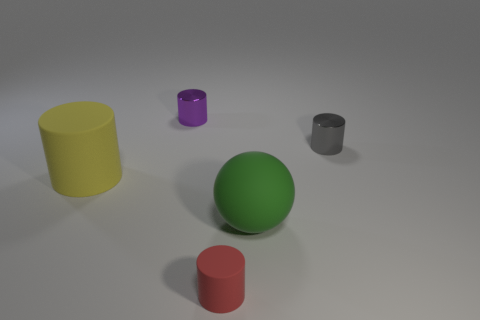The purple object that is the same shape as the red rubber object is what size?
Your answer should be very brief. Small. Are there any blue matte things that have the same shape as the tiny gray metallic thing?
Offer a terse response. No. Is the tiny cylinder right of the rubber ball made of the same material as the small cylinder on the left side of the red cylinder?
Provide a succinct answer. Yes. How many purple cylinders are made of the same material as the small red object?
Give a very brief answer. 0. The small matte thing is what color?
Your answer should be very brief. Red. Is the shape of the large rubber object that is on the left side of the big green matte object the same as the purple metal object left of the green matte ball?
Make the answer very short. Yes. What is the color of the cylinder behind the small gray cylinder?
Provide a short and direct response. Purple. Are there fewer matte cylinders that are behind the big yellow cylinder than cylinders that are in front of the tiny purple metallic object?
Provide a succinct answer. Yes. How many other things are the same material as the gray cylinder?
Offer a very short reply. 1. Are the gray cylinder and the red cylinder made of the same material?
Your answer should be compact. No. 